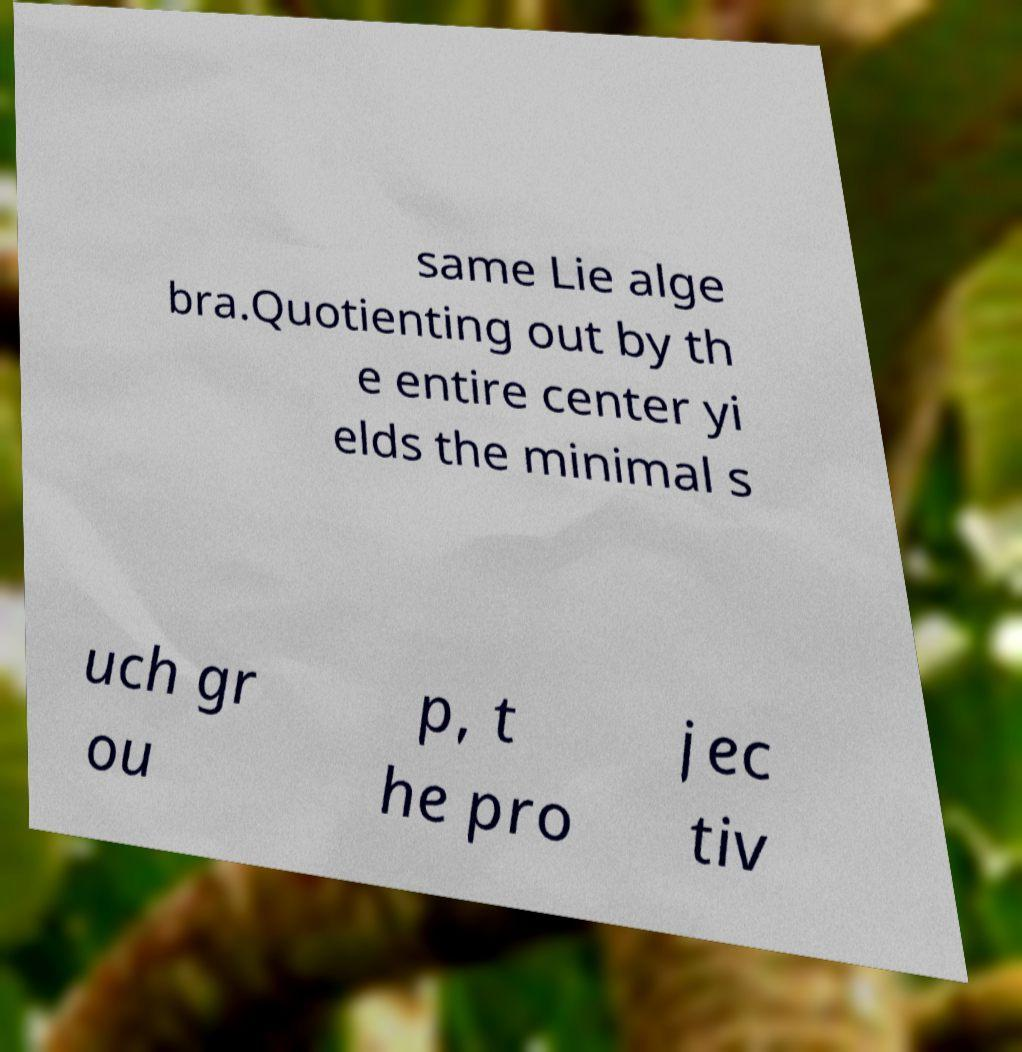There's text embedded in this image that I need extracted. Can you transcribe it verbatim? same Lie alge bra.Quotienting out by th e entire center yi elds the minimal s uch gr ou p, t he pro jec tiv 